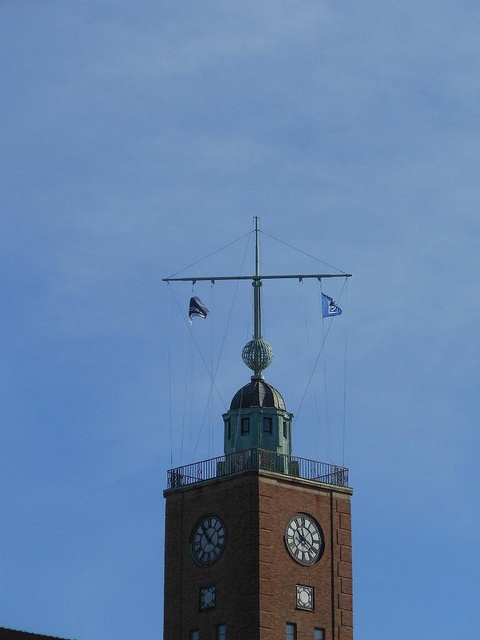Describe the objects in this image and their specific colors. I can see clock in gray, black, darkgray, and purple tones and clock in gray, black, darkblue, and blue tones in this image. 